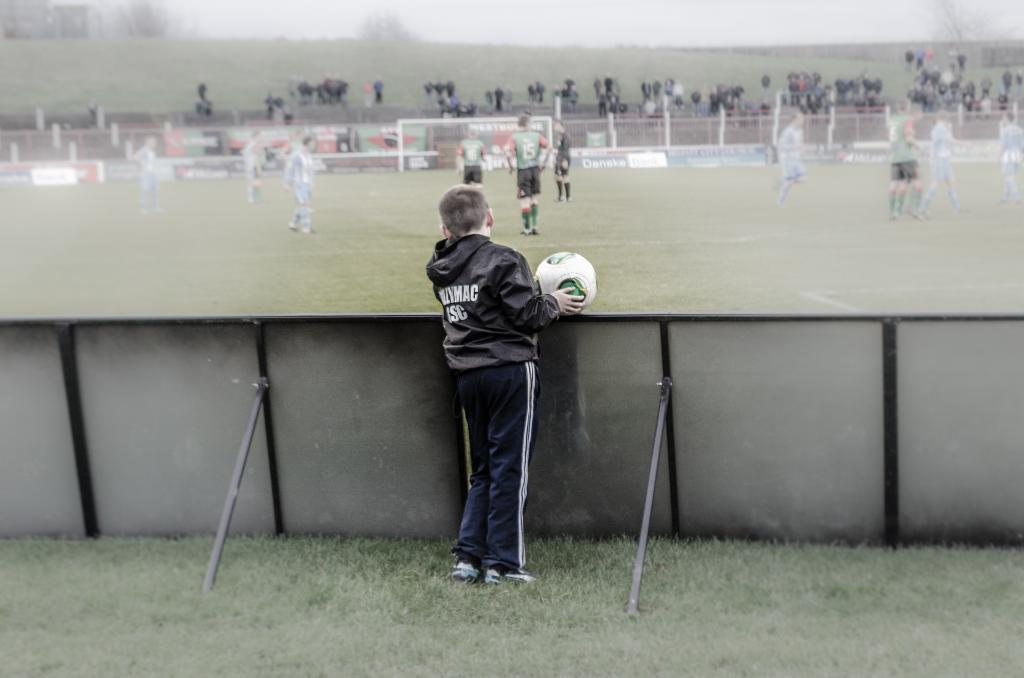Who is the main subject in the image? There is a boy in the image. What is the boy holding in the image? The boy is holding a football. Where is the boy positioned in relation to the football game? The boy is standing behind barricades. What is the setting of the image? The football game is taking place on a ground. What type of yak can be seen grazing on the football ground in the image? There is no yak present in the image; it features a boy holding a football and a group of people playing football on a ground. 